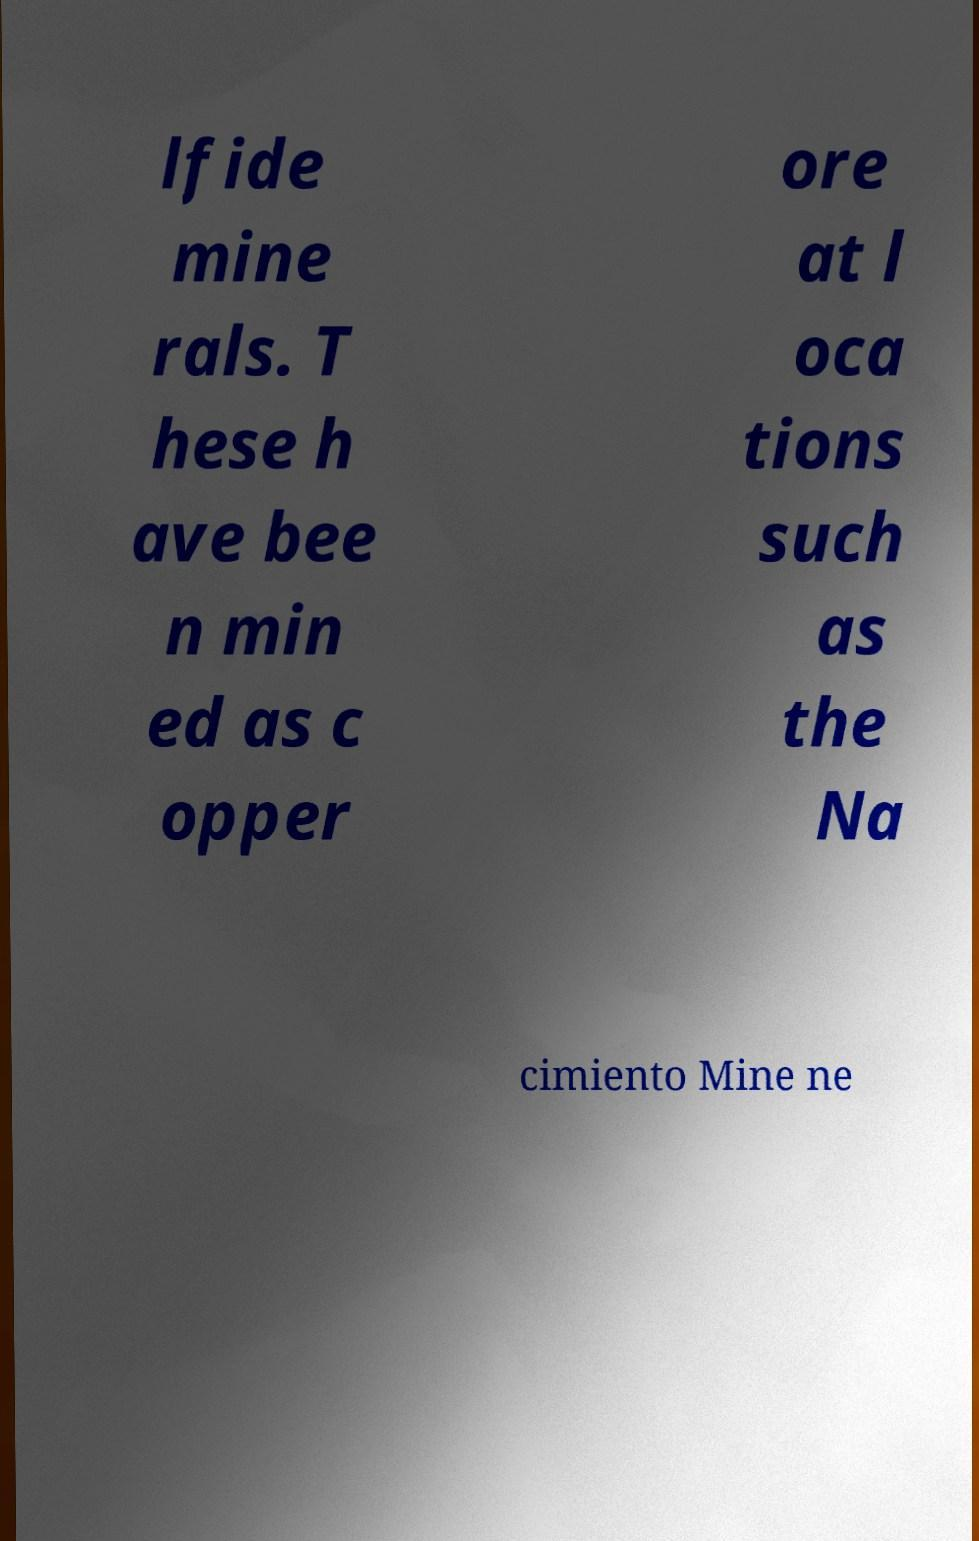For documentation purposes, I need the text within this image transcribed. Could you provide that? lfide mine rals. T hese h ave bee n min ed as c opper ore at l oca tions such as the Na cimiento Mine ne 